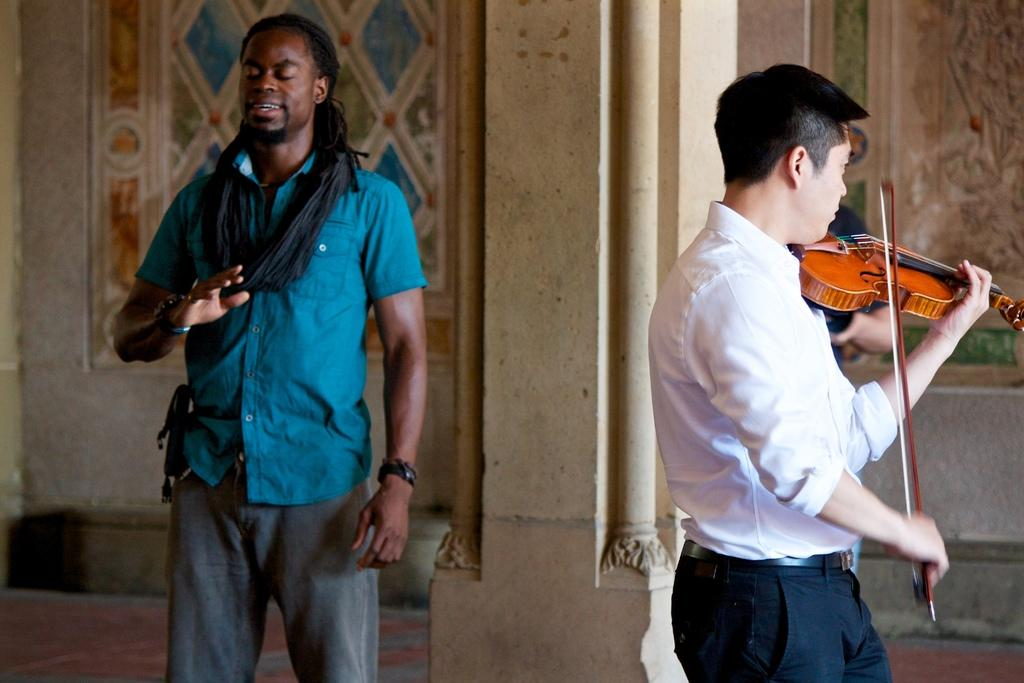How many people are in the image? There are two men in the image. What is one of the men doing in the image? One man is standing. What is the other man doing in the image? The other man is playing the violin. How many dolls are sitting on the gate in the image? There are no dolls or gates present in the image. Can you see a cat playing with a ball of yarn in the image? There is no cat or ball of yarn present in the image. 